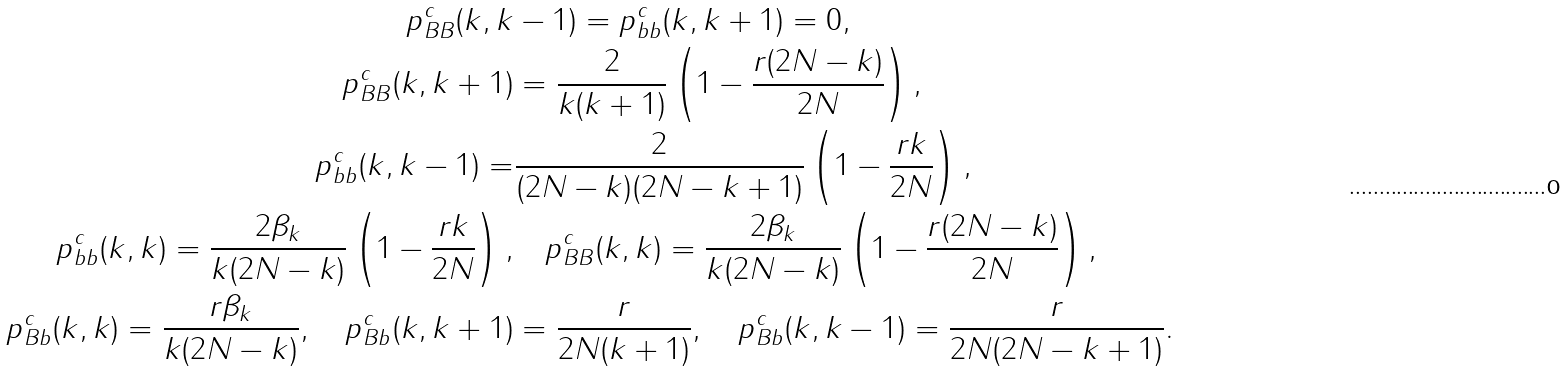Convert formula to latex. <formula><loc_0><loc_0><loc_500><loc_500>p _ { B B } ^ { c } ( k , k & - 1 ) = p _ { b b } ^ { c } ( k , k + 1 ) = 0 , \\ p _ { B B } ^ { c } ( k , k + 1 ) & = \frac { 2 } { k ( k + 1 ) } \left ( 1 - \frac { r ( 2 N - k ) } { 2 N } \right ) , \\ p _ { b b } ^ { c } ( k , k - 1 ) = & \frac { 2 } { ( 2 N - k ) ( 2 N - k + 1 ) } \left ( 1 - \frac { r k } { 2 N } \right ) , \\ p _ { b b } ^ { c } ( k , k ) = \frac { 2 \beta _ { k } } { k ( 2 N - k ) } \left ( 1 - \frac { r k } { 2 N } \right ) , & \quad p _ { B B } ^ { c } ( k , k ) = \frac { 2 \beta _ { k } } { k ( 2 N - k ) } \left ( 1 - \frac { r ( 2 N - k ) } { 2 N } \right ) , \\ p _ { B b } ^ { c } ( k , k ) = \frac { r \beta _ { k } } { k ( 2 N - k ) } , \quad p _ { B b } ^ { c } ( k , k + 1 ) & = \frac { r } { 2 N ( k + 1 ) } , \quad p _ { B b } ^ { c } ( k , k - 1 ) = \frac { r } { 2 N ( 2 N - k + 1 ) } .</formula> 